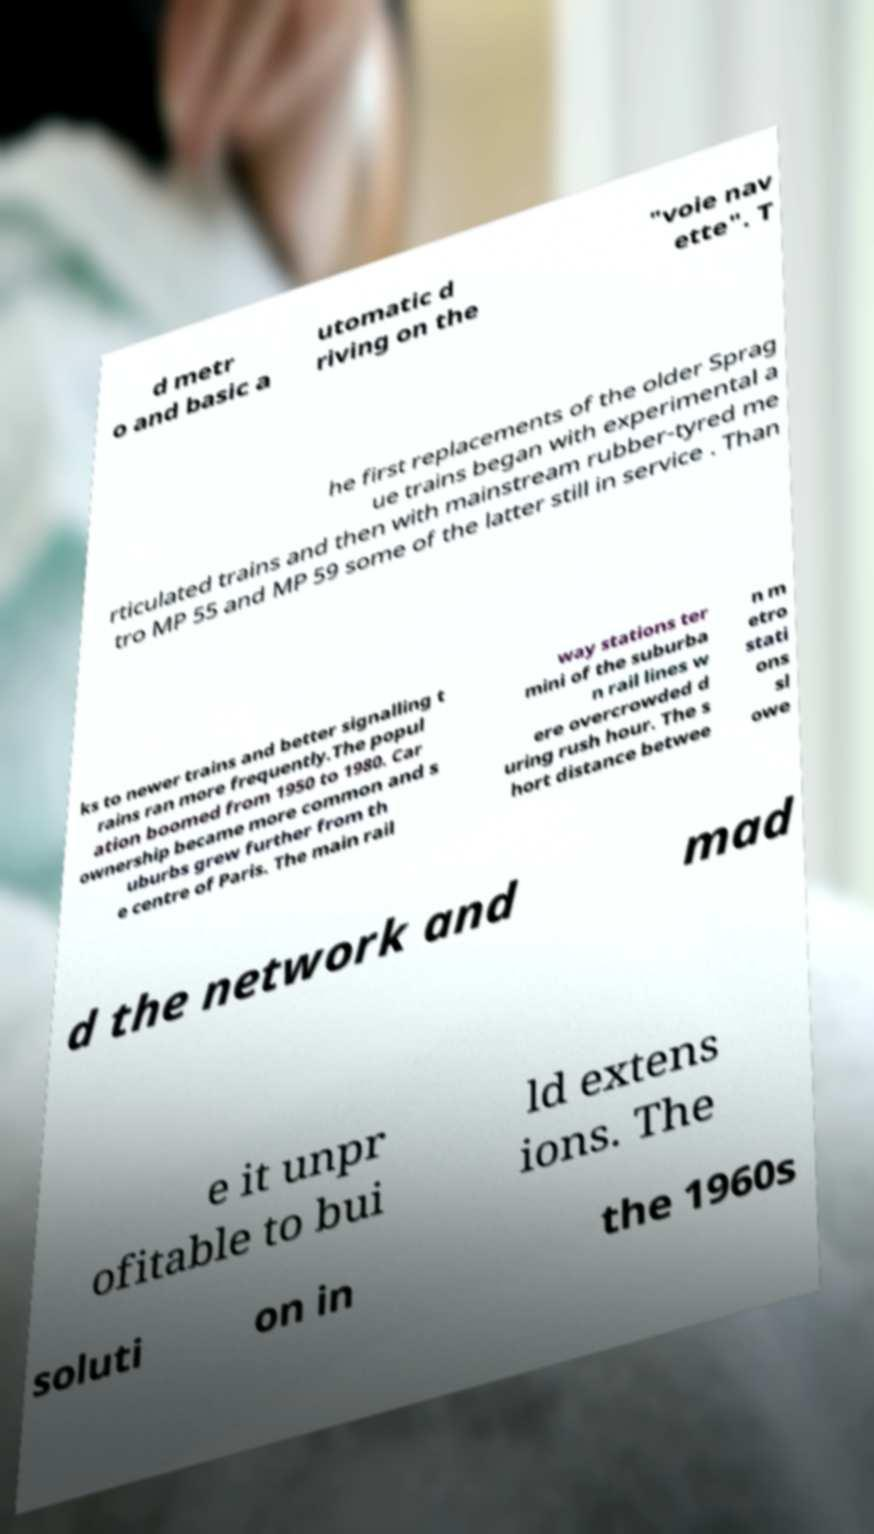Please identify and transcribe the text found in this image. d metr o and basic a utomatic d riving on the "voie nav ette". T he first replacements of the older Sprag ue trains began with experimental a rticulated trains and then with mainstream rubber-tyred me tro MP 55 and MP 59 some of the latter still in service . Than ks to newer trains and better signalling t rains ran more frequently.The popul ation boomed from 1950 to 1980. Car ownership became more common and s uburbs grew further from th e centre of Paris. The main rail way stations ter mini of the suburba n rail lines w ere overcrowded d uring rush hour. The s hort distance betwee n m etro stati ons sl owe d the network and mad e it unpr ofitable to bui ld extens ions. The soluti on in the 1960s 